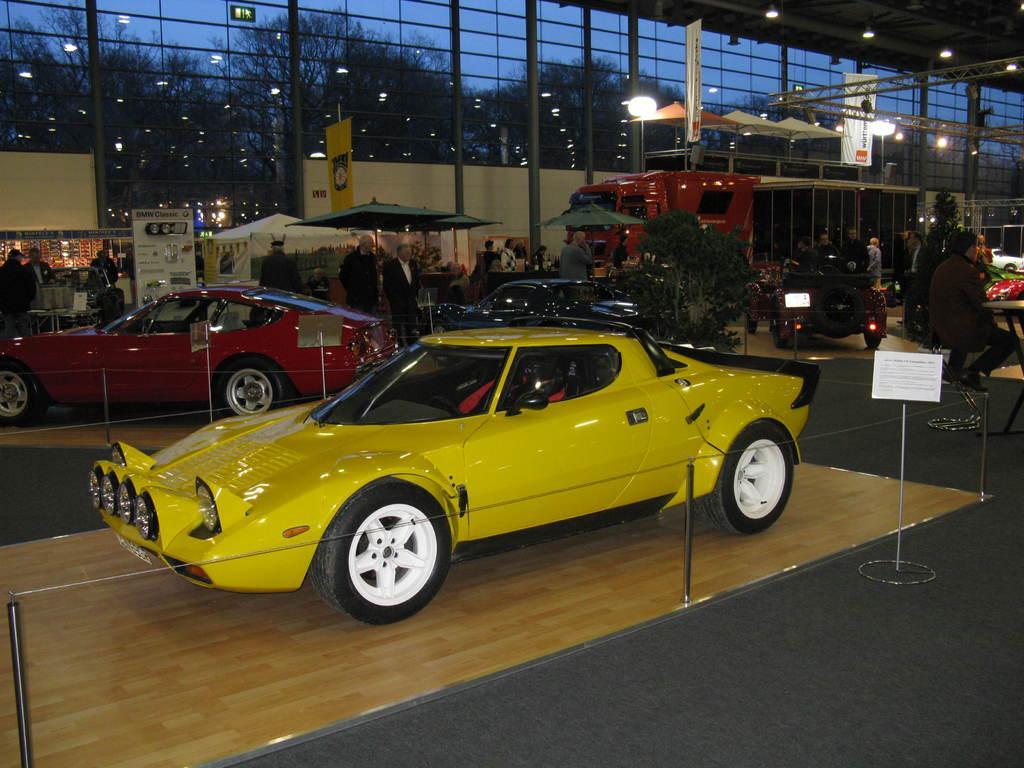Could you give a brief overview of what you see in this image? In the image there is a yellow car in the front followed by many cars in the back, this seems to be cars exhibition, there are many people walking and sitting on the back and there are tents and umbrellas on left side and the back there is a wall, behind it there are trees. 